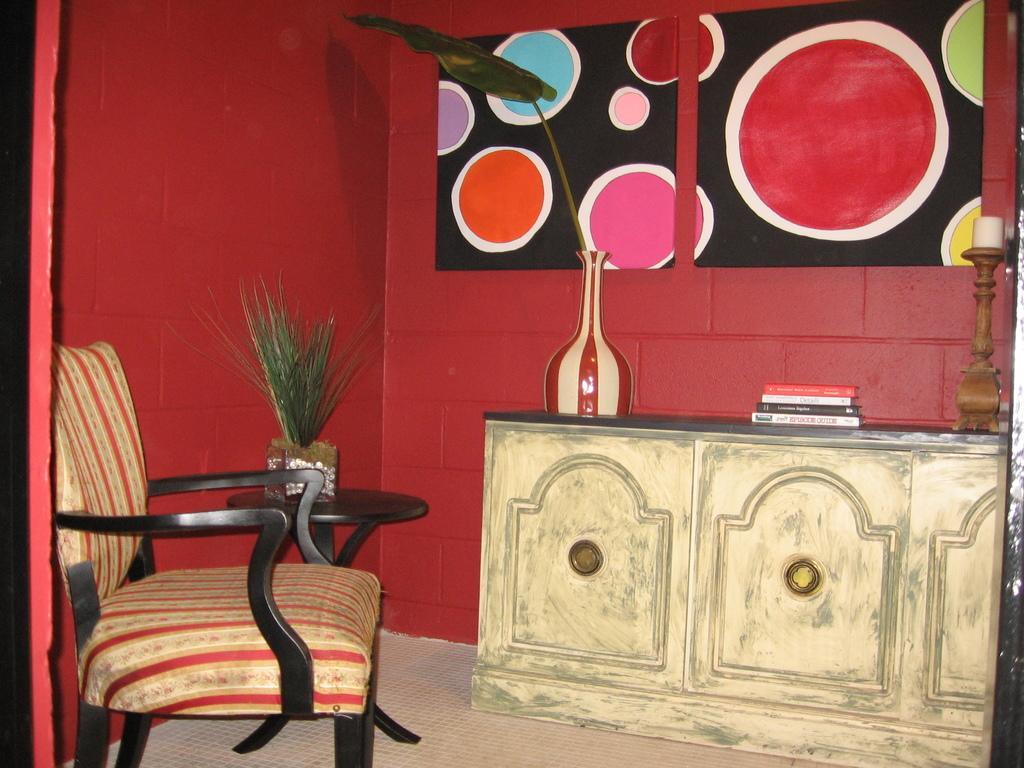Can you describe this image briefly? There is a chair and this is table. On the table there are books. And this is a plant. In the background there is a wall and this is frame. And this is floor. 